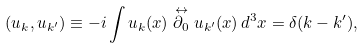Convert formula to latex. <formula><loc_0><loc_0><loc_500><loc_500>( u _ { k } , u _ { k ^ { \prime } } ) \equiv - i \int u _ { k } ( x ) \stackrel { \leftrightarrow } { \partial _ { 0 } } u _ { k ^ { \prime } } ( x ) \, d ^ { 3 } x = \delta ( { k } - { k ^ { \prime } } ) ,</formula> 